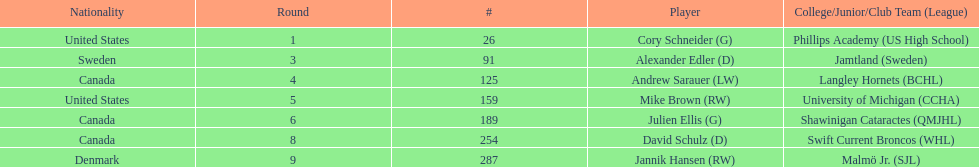How many canadian players are listed? 3. 